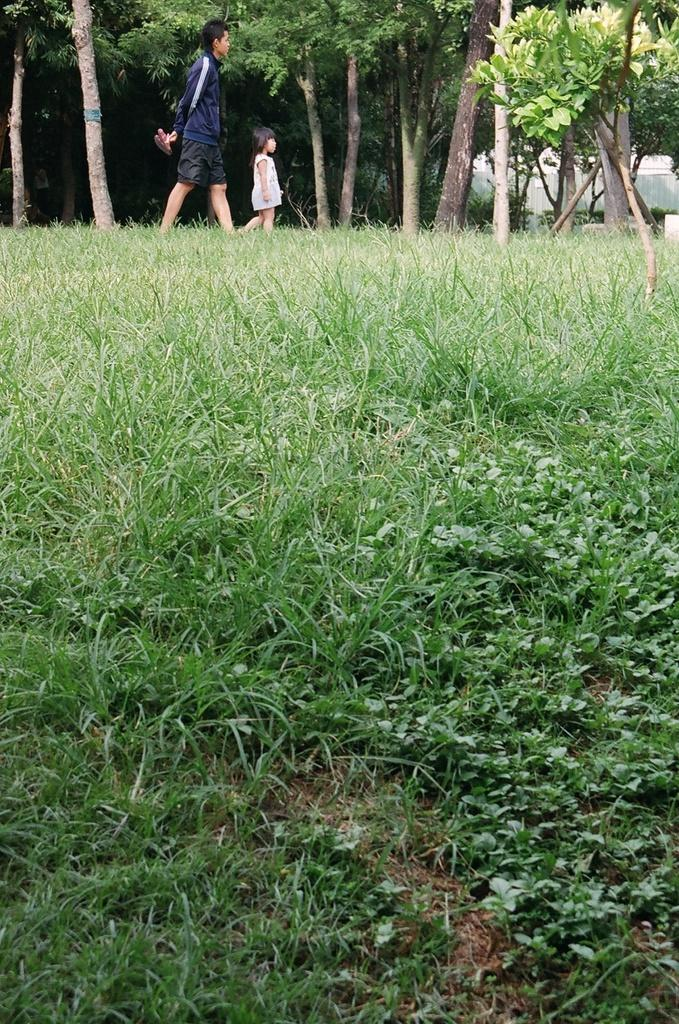Who is present in the image? There is a person and a child in the image. What are the person and child doing in the image? The person and child are walking on the surface of the grass. What can be seen in the background of the image? There are trees in the background of the image. What type of beef is the child holding in the image? There is no beef present in the image. 